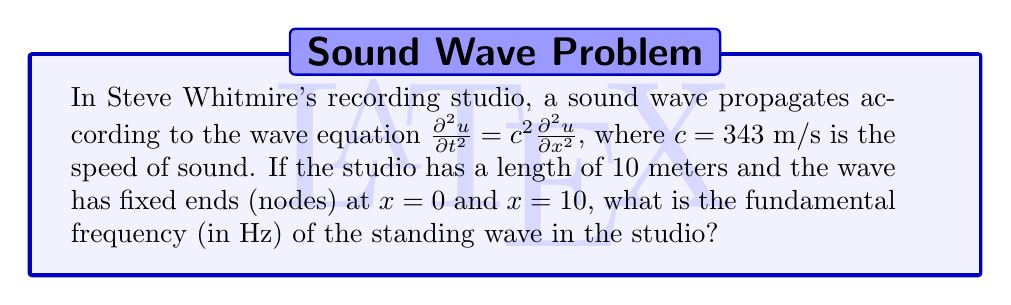Show me your answer to this math problem. To solve this problem, we'll follow these steps:

1) For a wave with fixed ends, the general solution is given by:
   $u(x,t) = \sin(\frac{n\pi x}{L}) \cos(\frac{n\pi c t}{L})$

   Where $L$ is the length of the studio and $n$ is a positive integer.

2) The fundamental frequency corresponds to $n = 1$. 

3) The angular frequency $\omega$ is given by:
   $\omega = \frac{\pi c}{L}$

4) The frequency $f$ is related to the angular frequency by:
   $f = \frac{\omega}{2\pi}$

5) Substituting the values:
   $f = \frac{c}{2L} = \frac{343}{2(10)} = 17.15$ Hz

Therefore, the fundamental frequency of the standing wave in Steve's studio is approximately 17.15 Hz.
Answer: 17.15 Hz 